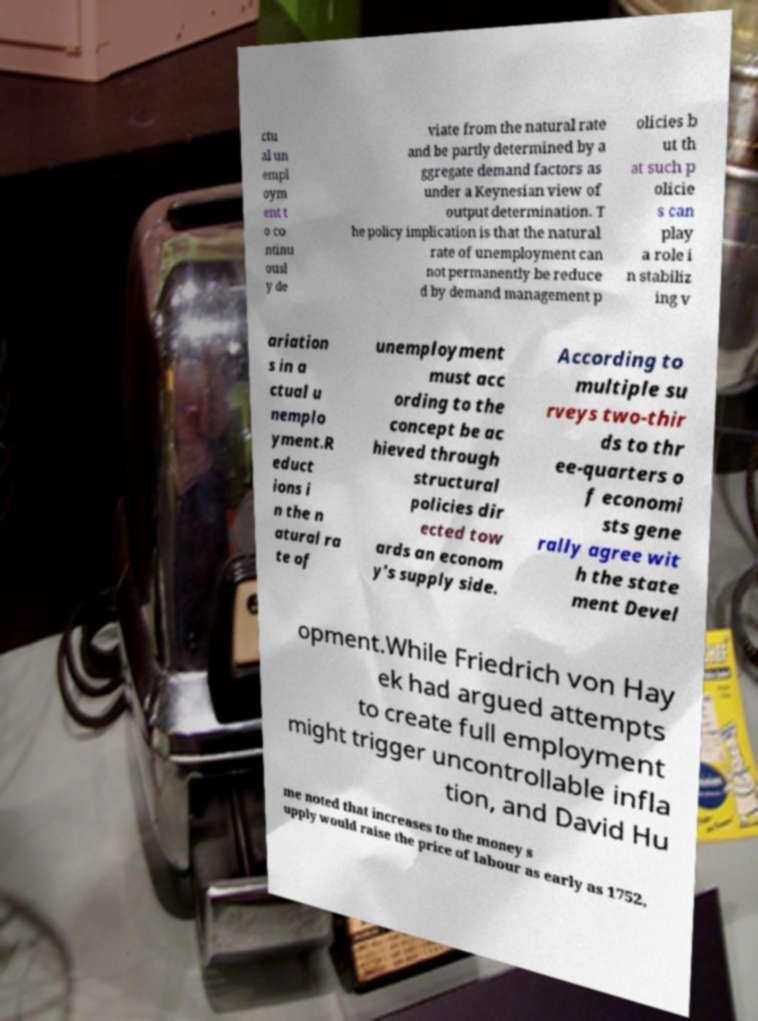Please read and relay the text visible in this image. What does it say? ctu al un empl oym ent t o co ntinu ousl y de viate from the natural rate and be partly determined by a ggregate demand factors as under a Keynesian view of output determination. T he policy implication is that the natural rate of unemployment can not permanently be reduce d by demand management p olicies b ut th at such p olicie s can play a role i n stabiliz ing v ariation s in a ctual u nemplo yment.R educt ions i n the n atural ra te of unemployment must acc ording to the concept be ac hieved through structural policies dir ected tow ards an econom y's supply side. According to multiple su rveys two-thir ds to thr ee-quarters o f economi sts gene rally agree wit h the state ment Devel opment.While Friedrich von Hay ek had argued attempts to create full employment might trigger uncontrollable infla tion, and David Hu me noted that increases to the money s upply would raise the price of labour as early as 1752, 